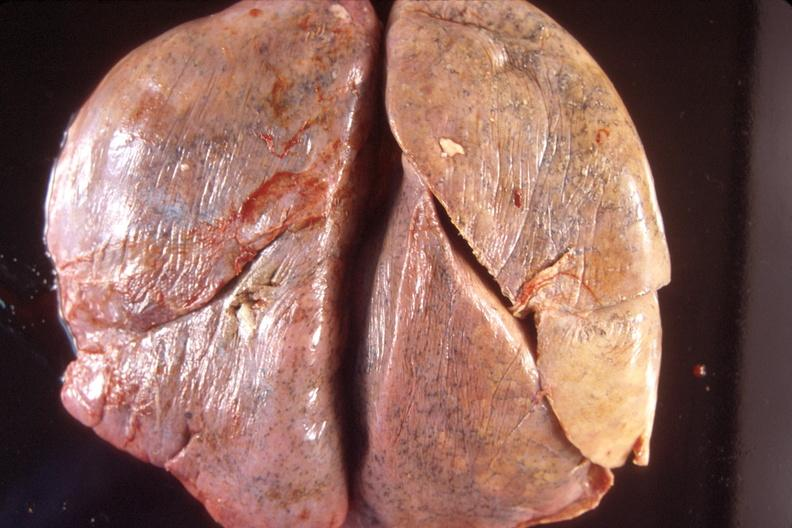what is present?
Answer the question using a single word or phrase. Respiratory 